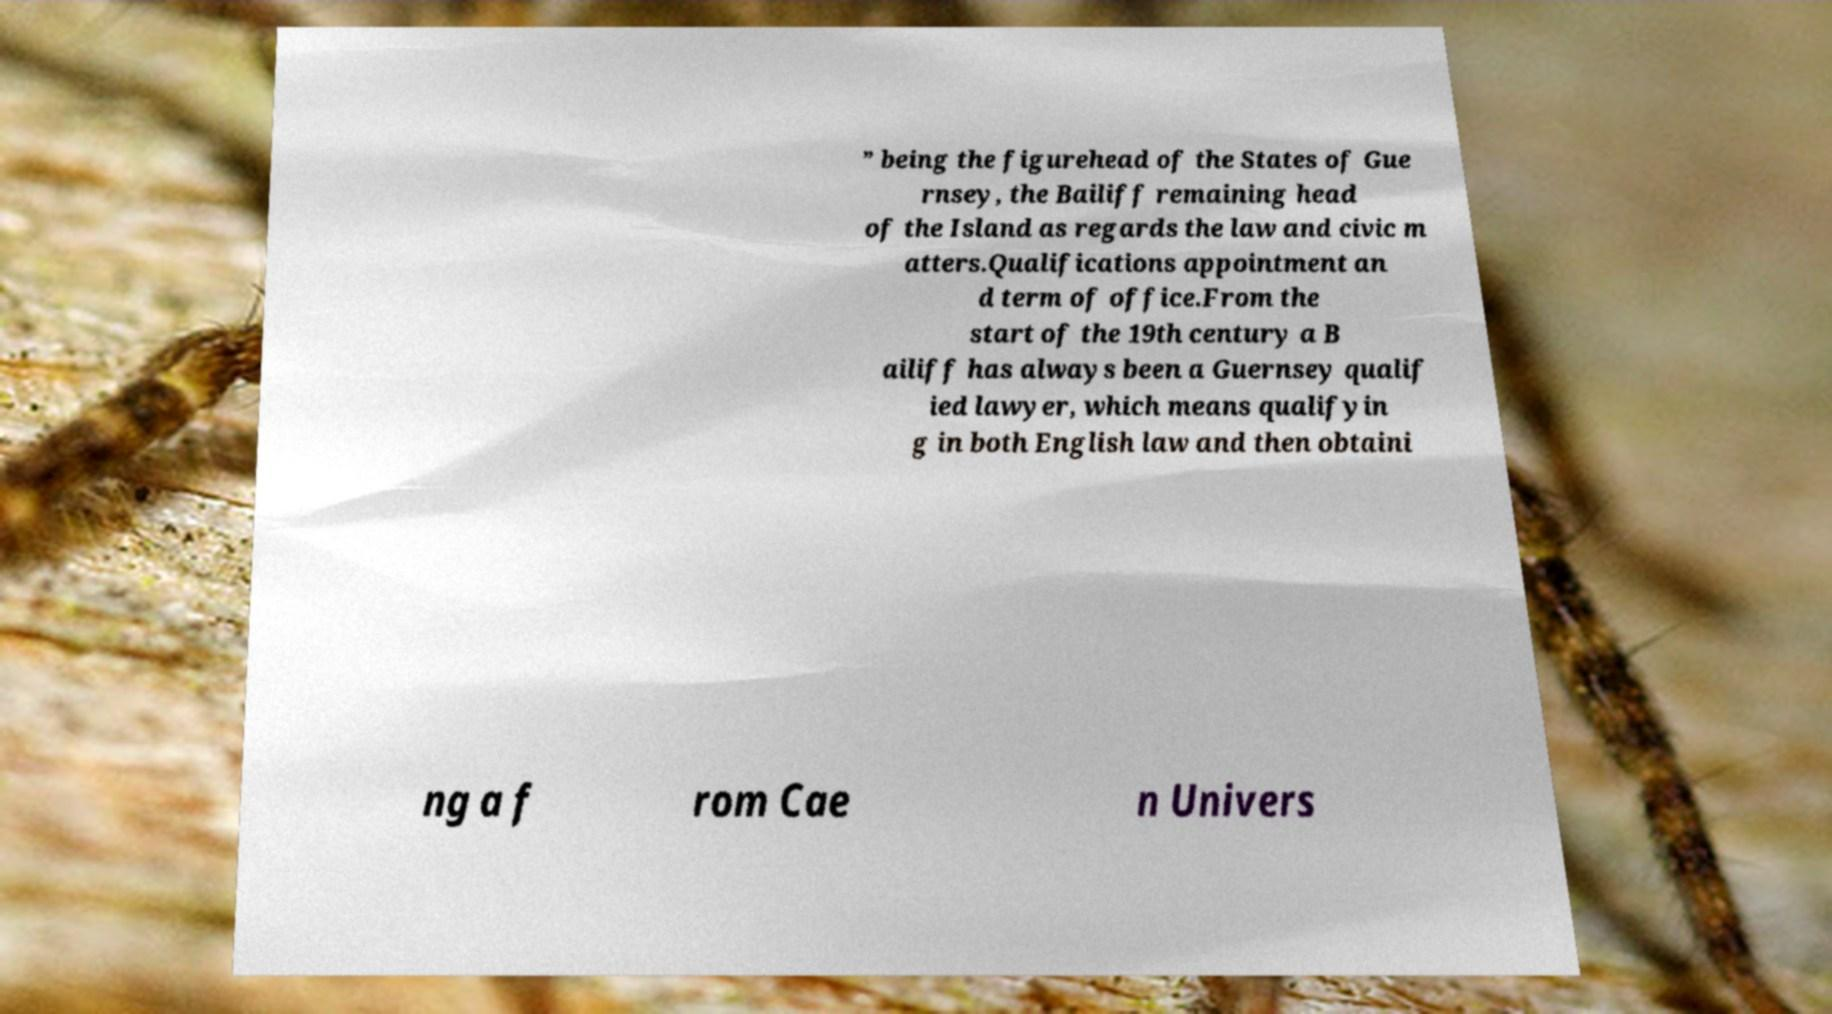Could you assist in decoding the text presented in this image and type it out clearly? ” being the figurehead of the States of Gue rnsey, the Bailiff remaining head of the Island as regards the law and civic m atters.Qualifications appointment an d term of office.From the start of the 19th century a B ailiff has always been a Guernsey qualif ied lawyer, which means qualifyin g in both English law and then obtaini ng a f rom Cae n Univers 